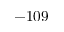Convert formula to latex. <formula><loc_0><loc_0><loc_500><loc_500>- 1 0 9</formula> 